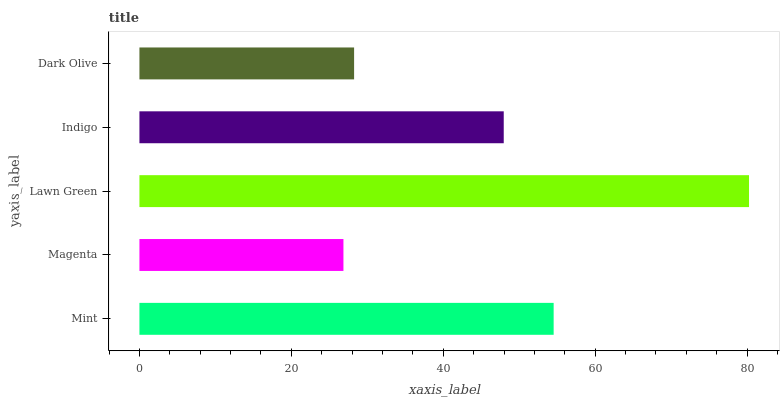Is Magenta the minimum?
Answer yes or no. Yes. Is Lawn Green the maximum?
Answer yes or no. Yes. Is Lawn Green the minimum?
Answer yes or no. No. Is Magenta the maximum?
Answer yes or no. No. Is Lawn Green greater than Magenta?
Answer yes or no. Yes. Is Magenta less than Lawn Green?
Answer yes or no. Yes. Is Magenta greater than Lawn Green?
Answer yes or no. No. Is Lawn Green less than Magenta?
Answer yes or no. No. Is Indigo the high median?
Answer yes or no. Yes. Is Indigo the low median?
Answer yes or no. Yes. Is Magenta the high median?
Answer yes or no. No. Is Mint the low median?
Answer yes or no. No. 